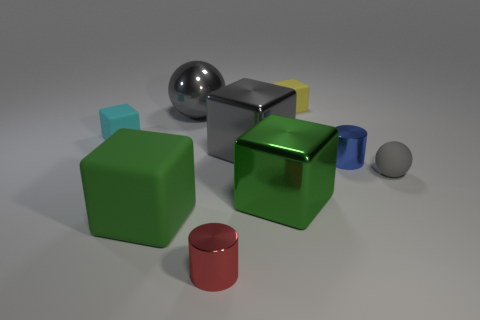What is the size of the gray block that is made of the same material as the large gray ball?
Give a very brief answer. Large. What is the shape of the object right of the cylinder that is to the right of the big green cube behind the big green rubber thing?
Make the answer very short. Sphere. Is the number of yellow rubber blocks that are on the left side of the red cylinder the same as the number of big objects?
Make the answer very short. No. What size is the cube that is the same color as the big matte object?
Give a very brief answer. Large. Do the red metal object and the big matte thing have the same shape?
Provide a succinct answer. No. What number of objects are rubber blocks that are to the left of the yellow matte cube or small cyan rubber objects?
Provide a short and direct response. 2. Is the number of red objects that are behind the small gray sphere the same as the number of big blocks to the left of the large sphere?
Your answer should be very brief. No. How many other things are there of the same shape as the green matte object?
Keep it short and to the point. 4. Do the metal cylinder behind the tiny gray object and the rubber thing that is in front of the small gray matte thing have the same size?
Make the answer very short. No. How many cylinders are gray rubber things or tiny yellow objects?
Keep it short and to the point. 0. 